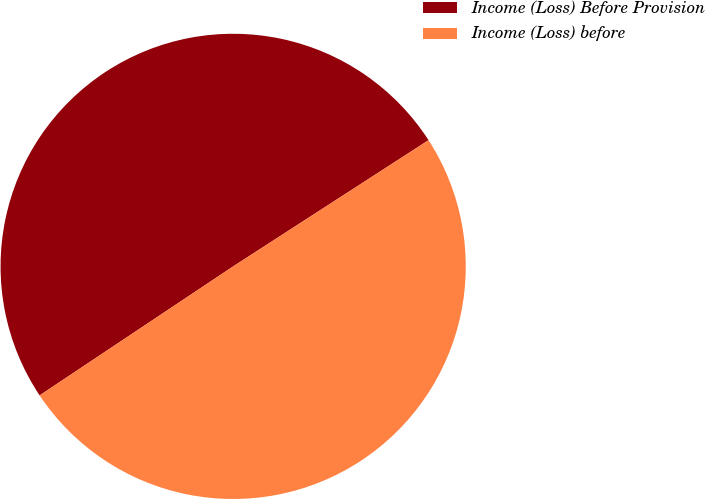<chart> <loc_0><loc_0><loc_500><loc_500><pie_chart><fcel>Income (Loss) Before Provision<fcel>Income (Loss) before<nl><fcel>50.23%<fcel>49.77%<nl></chart> 